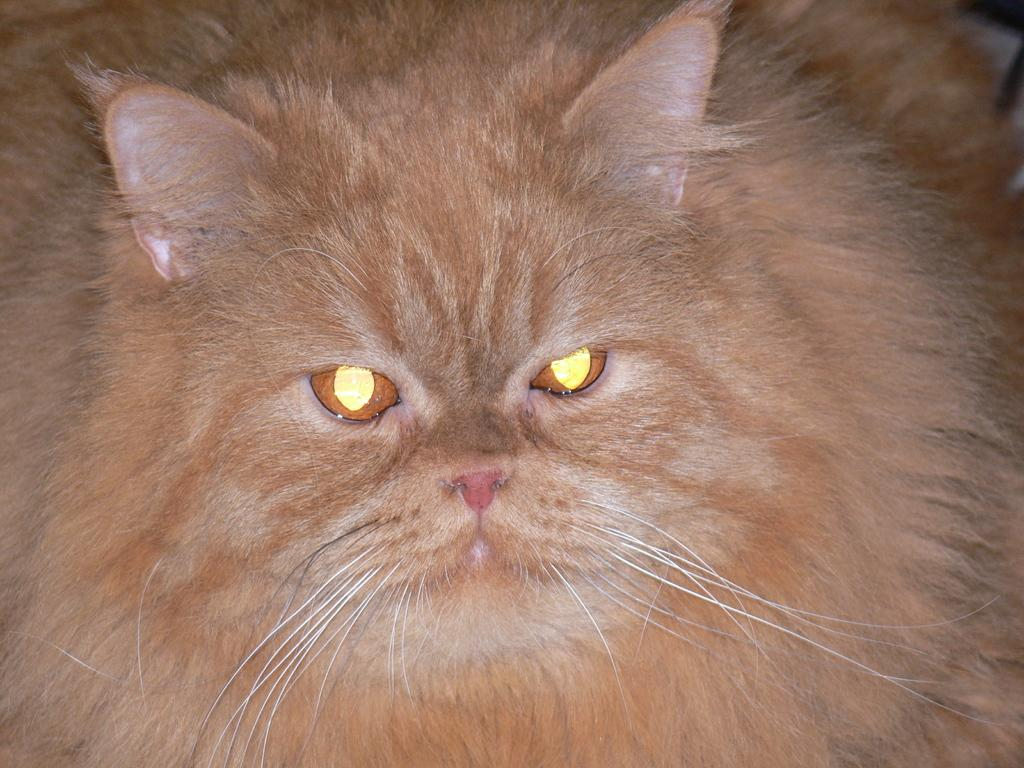What type of animal is present in the image? There is a cat in the image. What type of club can be seen in the image? There is no club present in the image; it features a cat. How many pizzas are visible in the image? There are no pizzas present in the image. 